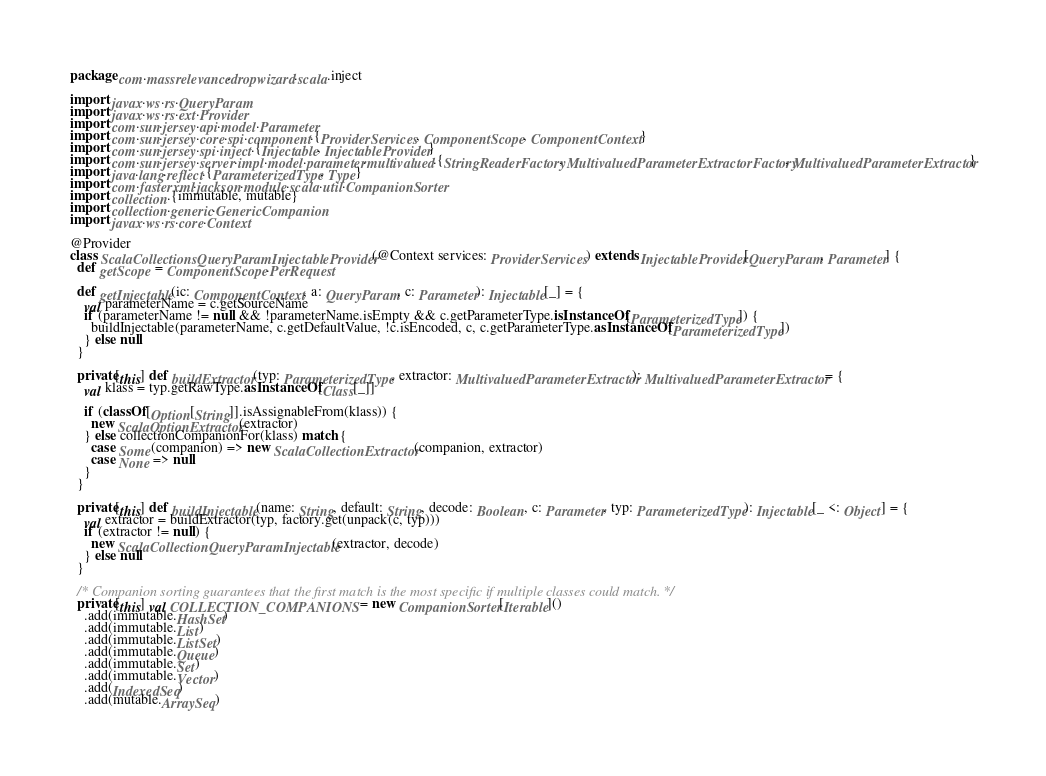Convert code to text. <code><loc_0><loc_0><loc_500><loc_500><_Scala_>package com.massrelevance.dropwizard.scala.inject

import javax.ws.rs.QueryParam
import javax.ws.rs.ext.Provider
import com.sun.jersey.api.model.Parameter
import com.sun.jersey.core.spi.component.{ProviderServices, ComponentScope, ComponentContext}
import com.sun.jersey.spi.inject.{Injectable, InjectableProvider}
import com.sun.jersey.server.impl.model.parameter.multivalued.{StringReaderFactory, MultivaluedParameterExtractorFactory, MultivaluedParameterExtractor}
import java.lang.reflect.{ParameterizedType, Type}
import com.fasterxml.jackson.module.scala.util.CompanionSorter
import collection.{immutable, mutable}
import collection.generic.GenericCompanion
import javax.ws.rs.core.Context

@Provider
class ScalaCollectionsQueryParamInjectableProvider (@Context services: ProviderServices) extends InjectableProvider[QueryParam, Parameter] {
  def getScope = ComponentScope.PerRequest

  def getInjectable(ic: ComponentContext, a: QueryParam, c: Parameter): Injectable[_] = {
    val parameterName = c.getSourceName
    if (parameterName != null && !parameterName.isEmpty && c.getParameterType.isInstanceOf[ParameterizedType]) {
      buildInjectable(parameterName, c.getDefaultValue, !c.isEncoded, c, c.getParameterType.asInstanceOf[ParameterizedType])
    } else null
  }

  private[this] def buildExtractor(typ: ParameterizedType, extractor: MultivaluedParameterExtractor): MultivaluedParameterExtractor = {
    val klass = typ.getRawType.asInstanceOf[Class[_]]

    if (classOf[Option[String]].isAssignableFrom(klass)) {
      new ScalaOptionExtractor(extractor)
    } else collectionCompanionFor(klass) match {
      case Some(companion) => new ScalaCollectionExtractor(companion, extractor)
      case None => null
    }
  }

  private[this] def buildInjectable(name: String, default: String, decode: Boolean, c: Parameter, typ: ParameterizedType): Injectable[_ <: Object] = {
    val extractor = buildExtractor(typ, factory.get(unpack(c, typ)))
    if (extractor != null) {
      new ScalaCollectionQueryParamInjectable(extractor, decode)
    } else null
  }

  /* Companion sorting guarantees that the first match is the most specific if multiple classes could match. */
  private[this] val COLLECTION_COMPANIONS = new CompanionSorter[Iterable]()
    .add(immutable.HashSet)
    .add(immutable.List)
    .add(immutable.ListSet)
    .add(immutable.Queue)
    .add(immutable.Set)
    .add(immutable.Vector)
    .add(IndexedSeq)
    .add(mutable.ArraySeq)</code> 